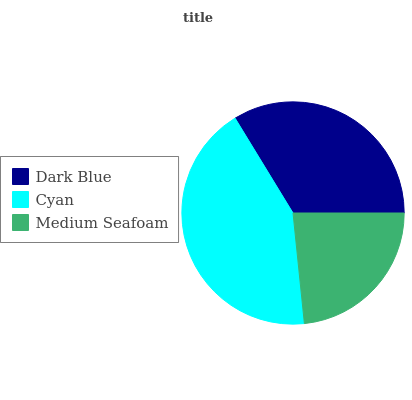Is Medium Seafoam the minimum?
Answer yes or no. Yes. Is Cyan the maximum?
Answer yes or no. Yes. Is Cyan the minimum?
Answer yes or no. No. Is Medium Seafoam the maximum?
Answer yes or no. No. Is Cyan greater than Medium Seafoam?
Answer yes or no. Yes. Is Medium Seafoam less than Cyan?
Answer yes or no. Yes. Is Medium Seafoam greater than Cyan?
Answer yes or no. No. Is Cyan less than Medium Seafoam?
Answer yes or no. No. Is Dark Blue the high median?
Answer yes or no. Yes. Is Dark Blue the low median?
Answer yes or no. Yes. Is Cyan the high median?
Answer yes or no. No. Is Cyan the low median?
Answer yes or no. No. 